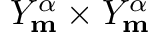Convert formula to latex. <formula><loc_0><loc_0><loc_500><loc_500>Y _ { m } ^ { \alpha } \times Y _ { m } ^ { \alpha }</formula> 